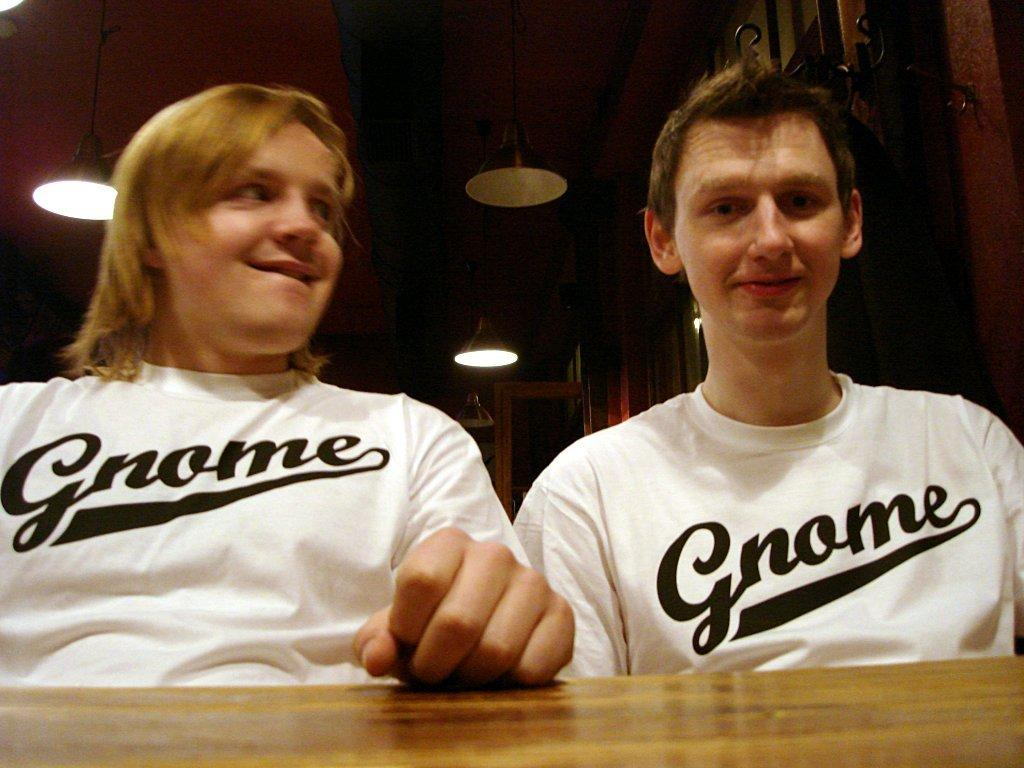<image>
Summarize the visual content of the image. man and woman wearing white shirts with gnome on them sitting at a table 